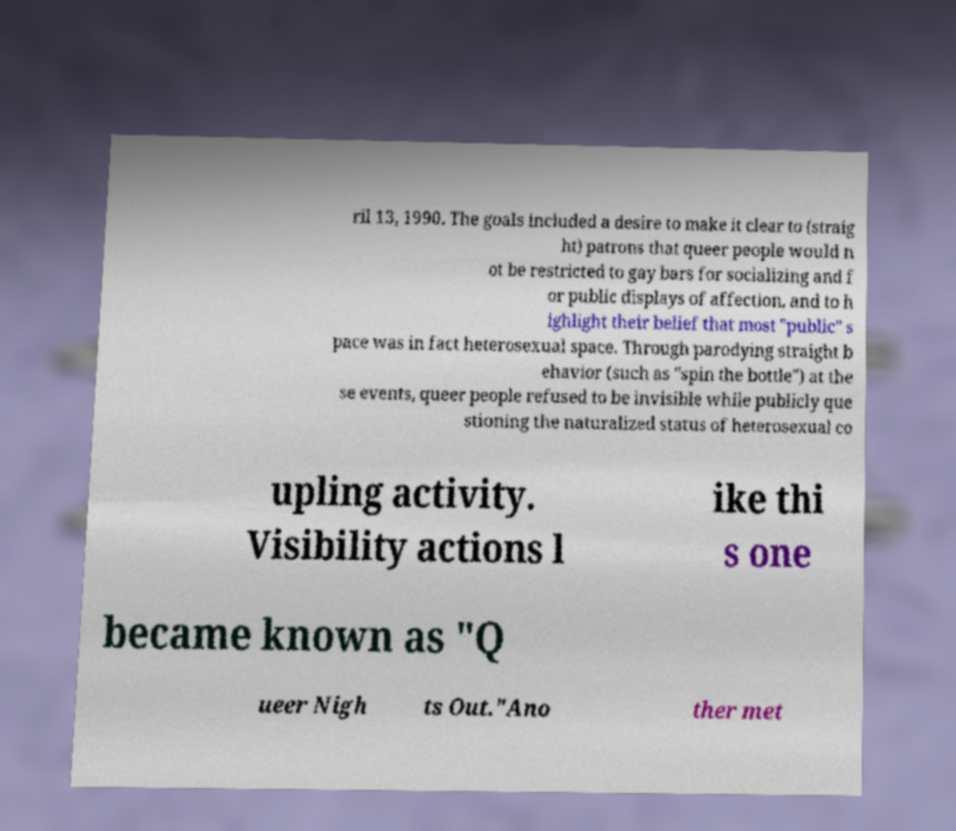Please read and relay the text visible in this image. What does it say? ril 13, 1990. The goals included a desire to make it clear to (straig ht) patrons that queer people would n ot be restricted to gay bars for socializing and f or public displays of affection, and to h ighlight their belief that most "public" s pace was in fact heterosexual space. Through parodying straight b ehavior (such as "spin the bottle") at the se events, queer people refused to be invisible while publicly que stioning the naturalized status of heterosexual co upling activity. Visibility actions l ike thi s one became known as "Q ueer Nigh ts Out."Ano ther met 